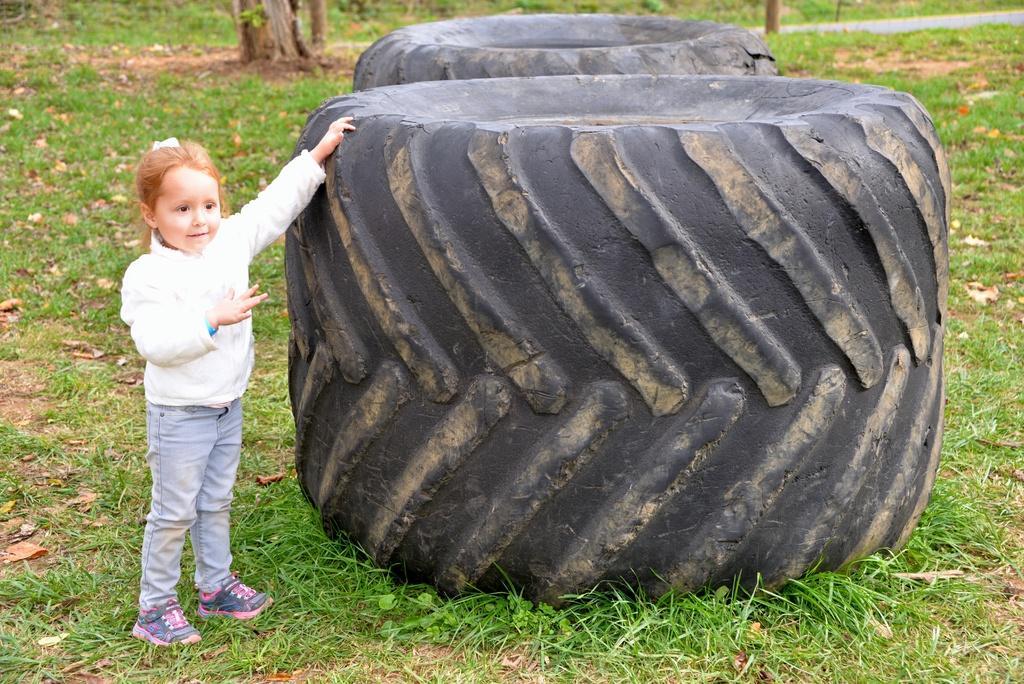Describe this image in one or two sentences. This image is taken outdoors. At the bottom of the image there is a ground with grass on it. In the background there are three trees. On the left side of the image a kid is standing on the ground. In the middle of the image there are two tires on the ground. 